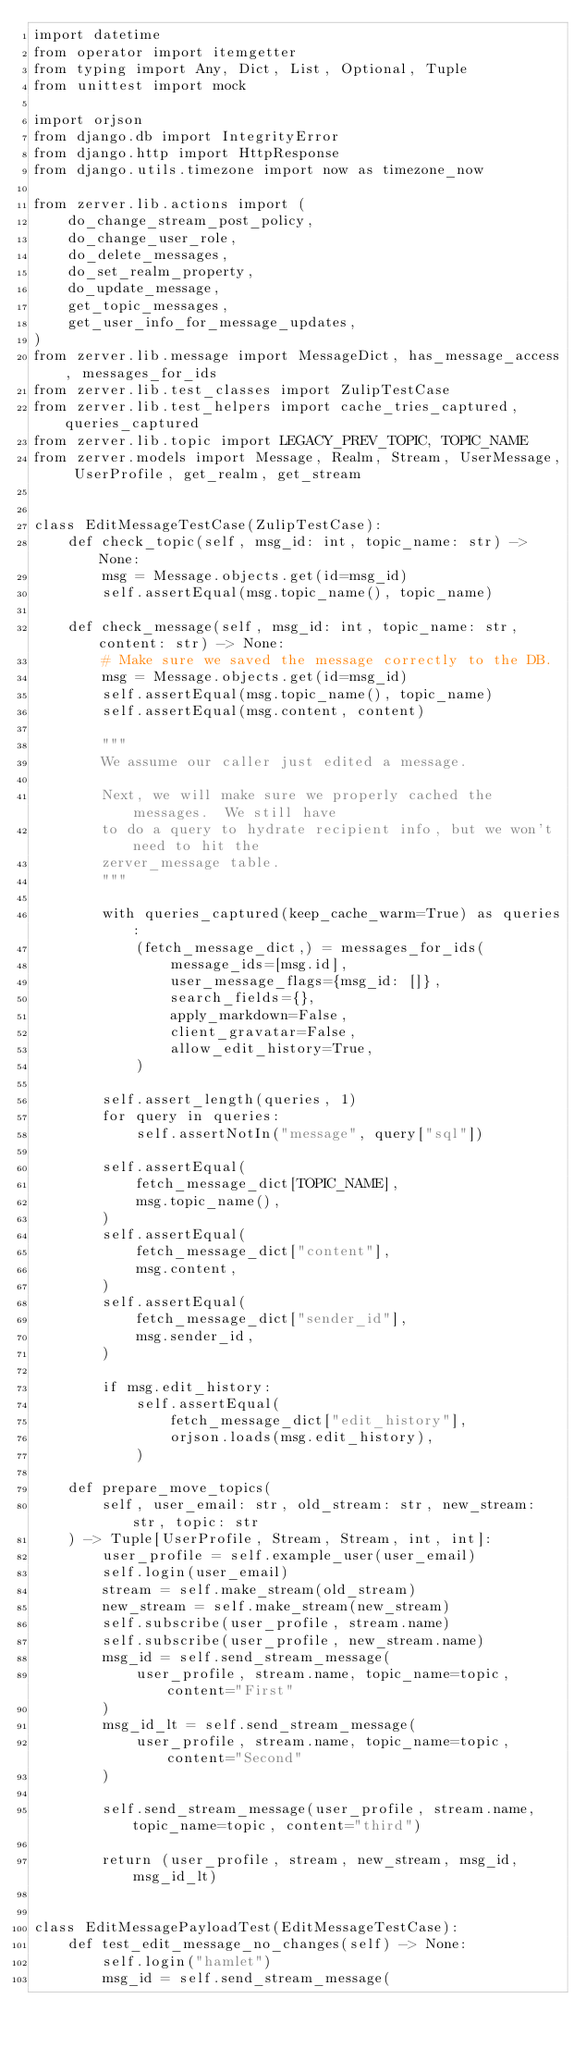Convert code to text. <code><loc_0><loc_0><loc_500><loc_500><_Python_>import datetime
from operator import itemgetter
from typing import Any, Dict, List, Optional, Tuple
from unittest import mock

import orjson
from django.db import IntegrityError
from django.http import HttpResponse
from django.utils.timezone import now as timezone_now

from zerver.lib.actions import (
    do_change_stream_post_policy,
    do_change_user_role,
    do_delete_messages,
    do_set_realm_property,
    do_update_message,
    get_topic_messages,
    get_user_info_for_message_updates,
)
from zerver.lib.message import MessageDict, has_message_access, messages_for_ids
from zerver.lib.test_classes import ZulipTestCase
from zerver.lib.test_helpers import cache_tries_captured, queries_captured
from zerver.lib.topic import LEGACY_PREV_TOPIC, TOPIC_NAME
from zerver.models import Message, Realm, Stream, UserMessage, UserProfile, get_realm, get_stream


class EditMessageTestCase(ZulipTestCase):
    def check_topic(self, msg_id: int, topic_name: str) -> None:
        msg = Message.objects.get(id=msg_id)
        self.assertEqual(msg.topic_name(), topic_name)

    def check_message(self, msg_id: int, topic_name: str, content: str) -> None:
        # Make sure we saved the message correctly to the DB.
        msg = Message.objects.get(id=msg_id)
        self.assertEqual(msg.topic_name(), topic_name)
        self.assertEqual(msg.content, content)

        """
        We assume our caller just edited a message.

        Next, we will make sure we properly cached the messages.  We still have
        to do a query to hydrate recipient info, but we won't need to hit the
        zerver_message table.
        """

        with queries_captured(keep_cache_warm=True) as queries:
            (fetch_message_dict,) = messages_for_ids(
                message_ids=[msg.id],
                user_message_flags={msg_id: []},
                search_fields={},
                apply_markdown=False,
                client_gravatar=False,
                allow_edit_history=True,
            )

        self.assert_length(queries, 1)
        for query in queries:
            self.assertNotIn("message", query["sql"])

        self.assertEqual(
            fetch_message_dict[TOPIC_NAME],
            msg.topic_name(),
        )
        self.assertEqual(
            fetch_message_dict["content"],
            msg.content,
        )
        self.assertEqual(
            fetch_message_dict["sender_id"],
            msg.sender_id,
        )

        if msg.edit_history:
            self.assertEqual(
                fetch_message_dict["edit_history"],
                orjson.loads(msg.edit_history),
            )

    def prepare_move_topics(
        self, user_email: str, old_stream: str, new_stream: str, topic: str
    ) -> Tuple[UserProfile, Stream, Stream, int, int]:
        user_profile = self.example_user(user_email)
        self.login(user_email)
        stream = self.make_stream(old_stream)
        new_stream = self.make_stream(new_stream)
        self.subscribe(user_profile, stream.name)
        self.subscribe(user_profile, new_stream.name)
        msg_id = self.send_stream_message(
            user_profile, stream.name, topic_name=topic, content="First"
        )
        msg_id_lt = self.send_stream_message(
            user_profile, stream.name, topic_name=topic, content="Second"
        )

        self.send_stream_message(user_profile, stream.name, topic_name=topic, content="third")

        return (user_profile, stream, new_stream, msg_id, msg_id_lt)


class EditMessagePayloadTest(EditMessageTestCase):
    def test_edit_message_no_changes(self) -> None:
        self.login("hamlet")
        msg_id = self.send_stream_message(</code> 